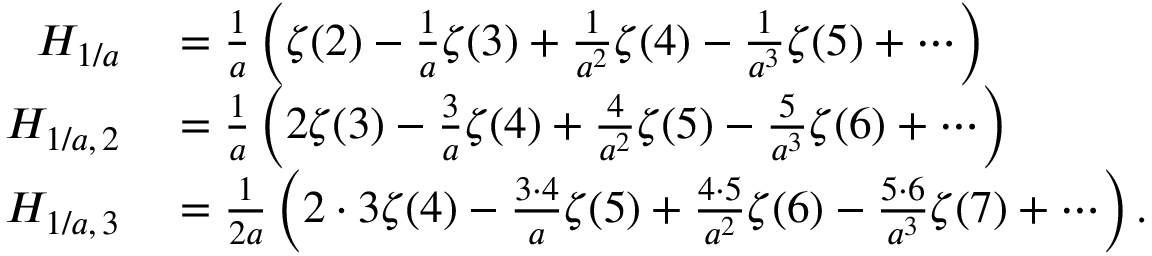Convert formula to latex. <formula><loc_0><loc_0><loc_500><loc_500>\begin{array} { r l } { H _ { 1 / a } } & = { \frac { 1 } { a } } \left ( \zeta ( 2 ) - { \frac { 1 } { a } } \zeta ( 3 ) + { \frac { 1 } { a ^ { 2 } } } \zeta ( 4 ) - { \frac { 1 } { a ^ { 3 } } } \zeta ( 5 ) + \cdots \right ) } \\ { H _ { 1 / a , \, 2 } } & = { \frac { 1 } { a } } \left ( 2 \zeta ( 3 ) - { \frac { 3 } { a } } \zeta ( 4 ) + { \frac { 4 } { a ^ { 2 } } } \zeta ( 5 ) - { \frac { 5 } { a ^ { 3 } } } \zeta ( 6 ) + \cdots \right ) } \\ { H _ { 1 / a , \, 3 } } & = { \frac { 1 } { 2 a } } \left ( 2 \cdot 3 \zeta ( 4 ) - { \frac { 3 \cdot 4 } { a } } \zeta ( 5 ) + { \frac { 4 \cdot 5 } { a ^ { 2 } } } \zeta ( 6 ) - { \frac { 5 \cdot 6 } { a ^ { 3 } } } \zeta ( 7 ) + \cdots \right ) . } \end{array}</formula> 